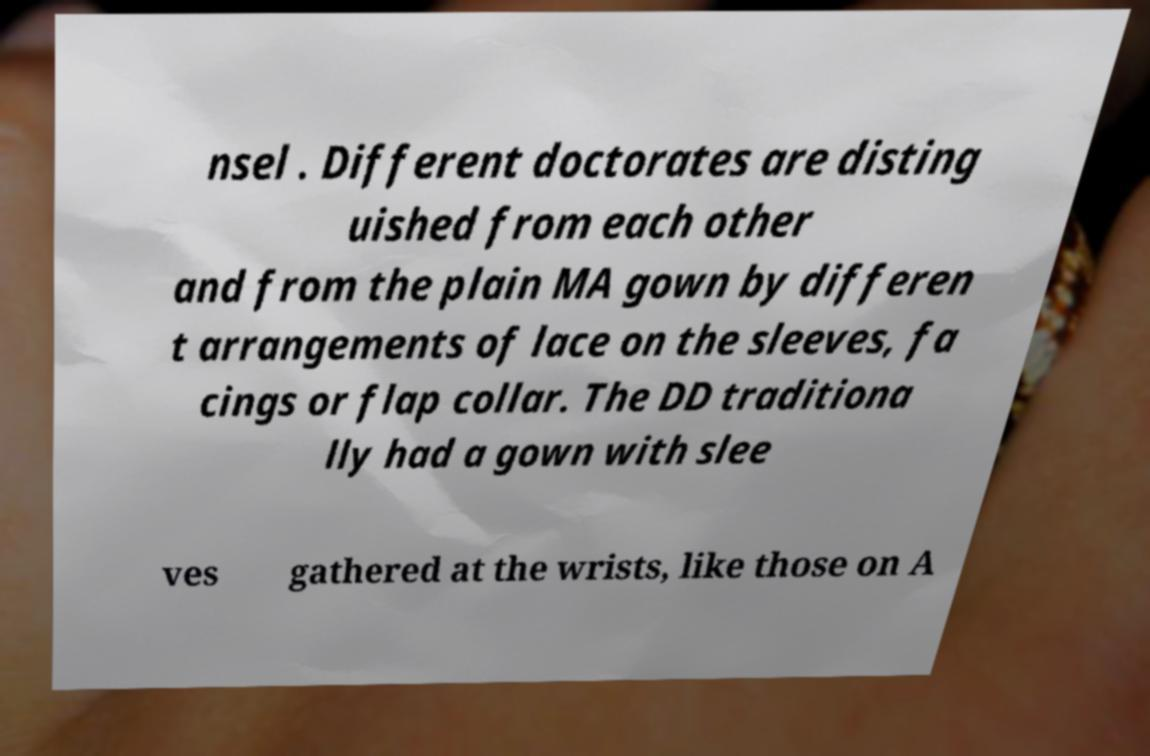Can you accurately transcribe the text from the provided image for me? nsel . Different doctorates are disting uished from each other and from the plain MA gown by differen t arrangements of lace on the sleeves, fa cings or flap collar. The DD traditiona lly had a gown with slee ves gathered at the wrists, like those on A 